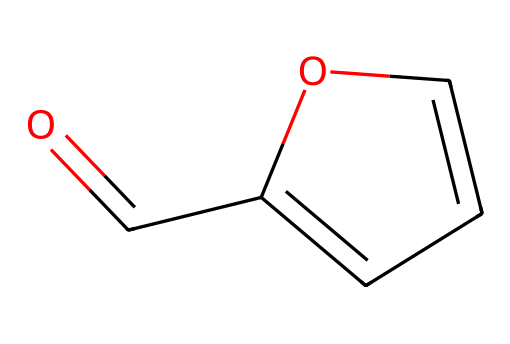What is the name of this chemical? The chemical structure provided corresponds to furfural, which is derived from agricultural byproducts and is an aldehyde.
Answer: furfural How many carbon atoms are in furfural? By analyzing the structure, there are five carbon atoms visible in the rings and chains.
Answer: 5 What type of functional group does furfural contain? The aldehyde group is characterized by the presence of the carbonyl functional group (C=O) at the end of the carbon chain in furfural.
Answer: aldehyde What is the total number of hydrogen atoms in furfural? Counting the hydrogen atoms associated with the carbon skeleton visually, furfural has four hydrogen atoms.
Answer: 4 From what types of sources is furfural typically derived? Furfural is primarily derived from the processing of agricultural residues such as corn cobs, sugarcane bagasse, and other lignocellulosic materials.
Answer: agricultural byproducts What physical state does furfural typically exist in at room temperature? Furfural is generally recognized as a liquid at room temperature due to its low boiling point, reflecting its physical properties as an organic compound.
Answer: liquid What property does the presence of the aldehyde group confer on furfural? The aldehyde group contributes to the reactivity and many characteristic properties, including its ability to participate in oxidation reactions and form various derivatives.
Answer: reactivity 